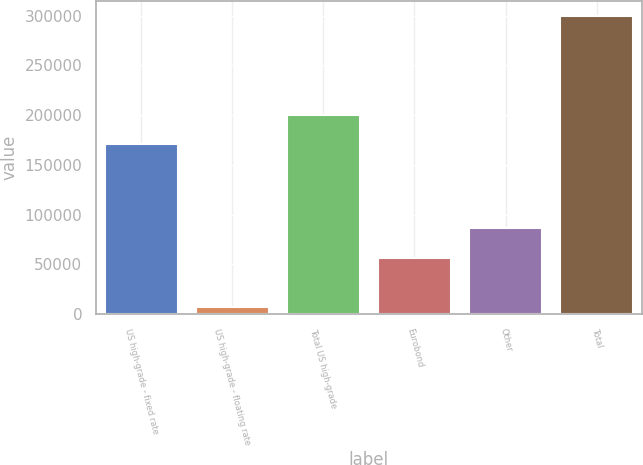<chart> <loc_0><loc_0><loc_500><loc_500><bar_chart><fcel>US high-grade - fixed rate<fcel>US high-grade - floating rate<fcel>Total US high-grade<fcel>Eurobond<fcel>Other<fcel>Total<nl><fcel>170519<fcel>6629<fcel>199785<fcel>56778<fcel>86043.7<fcel>299286<nl></chart> 